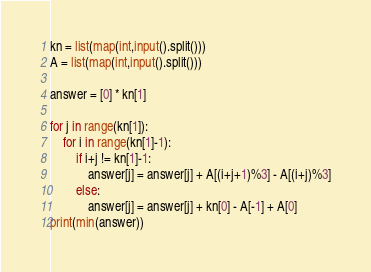Convert code to text. <code><loc_0><loc_0><loc_500><loc_500><_Python_>kn = list(map(int,input().split()))
A = list(map(int,input().split()))

answer = [0] * kn[1]

for j in range(kn[1]):
    for i in range(kn[1]-1):
        if i+j != kn[1]-1:
            answer[j] = answer[j] + A[(i+j+1)%3] - A[(i+j)%3]
        else:
            answer[j] = answer[j] + kn[0] - A[-1] + A[0]
print(min(answer))</code> 